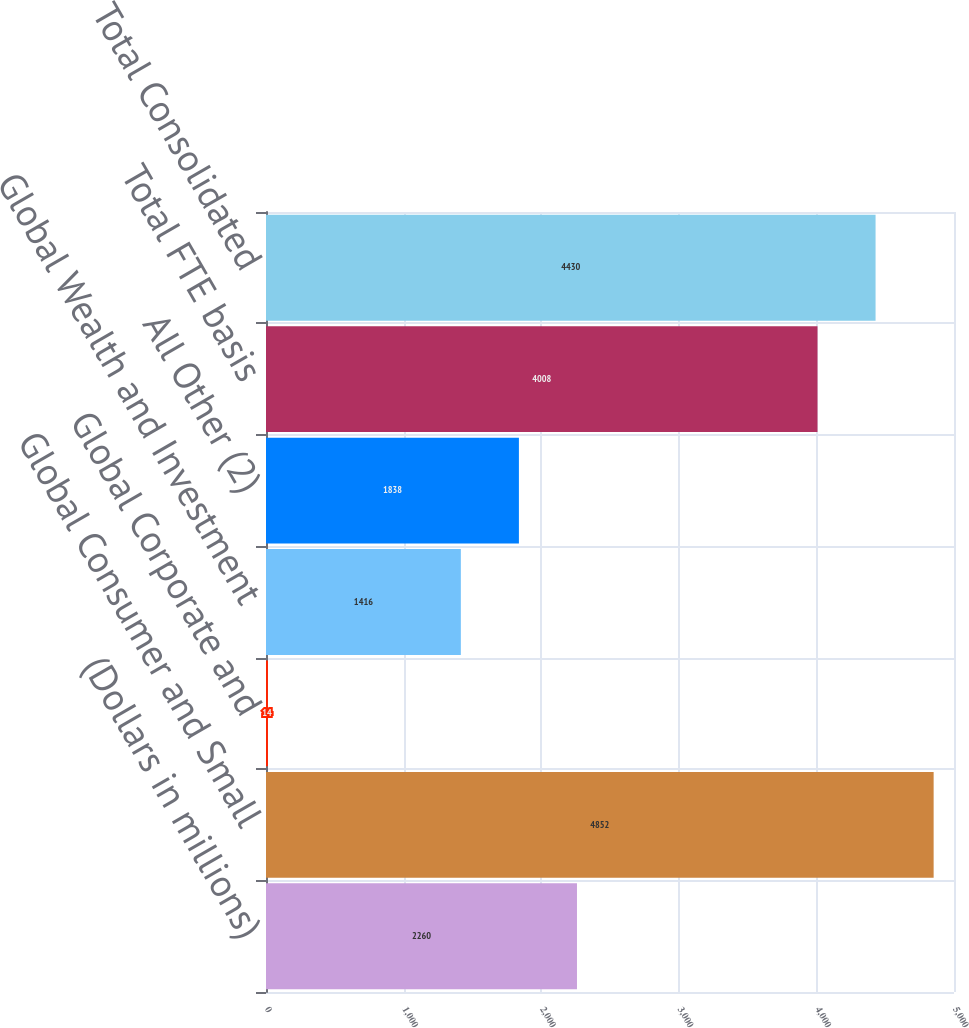Convert chart. <chart><loc_0><loc_0><loc_500><loc_500><bar_chart><fcel>(Dollars in millions)<fcel>Global Consumer and Small<fcel>Global Corporate and<fcel>Global Wealth and Investment<fcel>All Other (2)<fcel>Total FTE basis<fcel>Total Consolidated<nl><fcel>2260<fcel>4852<fcel>14<fcel>1416<fcel>1838<fcel>4008<fcel>4430<nl></chart> 